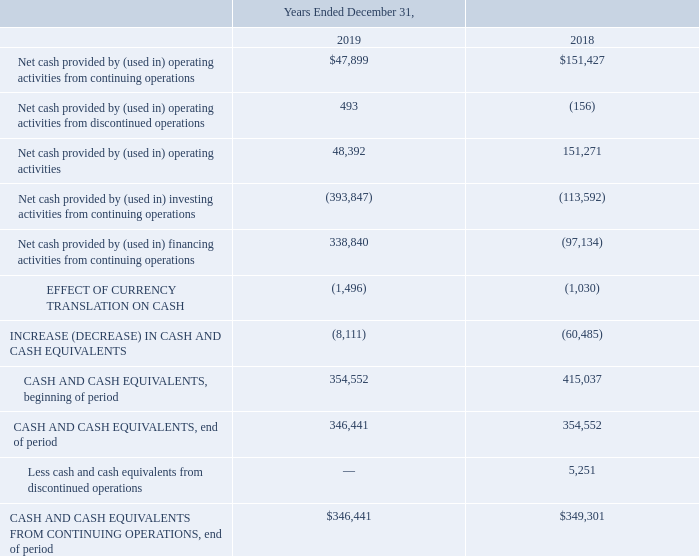Share Repurchase
On December 18, 2019, the Board of Directors authorized to remove the expiration date to the Company’s common stock share repurchase program and increase the authorized amount by $25.1 million increasing the authorization to repurchase shares up to a total of $50.0 million. As of December 31, 2019, a total of $50.0 million remained available for future share repurchases. We repurchased 1.7 million shares for $95.1 million and 0.4 million shares for $30.0 million in fiscal 2018 and 2017, respectively. There were no shares repurchased in fiscal 2019. CASH FLOWS
A summary of our cash provided by and used in operating, investing, and financing activities is as follows (in thousands):
What did the Board of Directors authorize in 2019? To remove the expiration date to the company’s common stock share repurchase program and increase the authorized amount by $25.1 million increasing the authorization to repurchase shares up to a total of $50.0 million. What was the Net cash provided by (used in) operating activities from continuing operations in 2019?
Answer scale should be: thousand. $47,899. What does the table show? Summary of our cash provided by and used in operating, investing, and financing activities. What was the change in Net cash provided by (used in) operating activities from continuing operations between 2018 and 2019?
Answer scale should be: thousand. $47,899-$151,427
Answer: -103528. What was the change in Net cash provided by (used in) operating activities between 2018 and 2019?
Answer scale should be: thousand. 48,392-151,271
Answer: -102879. What was the percentage change in cash and cash equivalents from continuing operations at the end of the period between 2018 and 2019?
Answer scale should be: percent. ($346,441-$349,301)/$349,301
Answer: -0.82. 